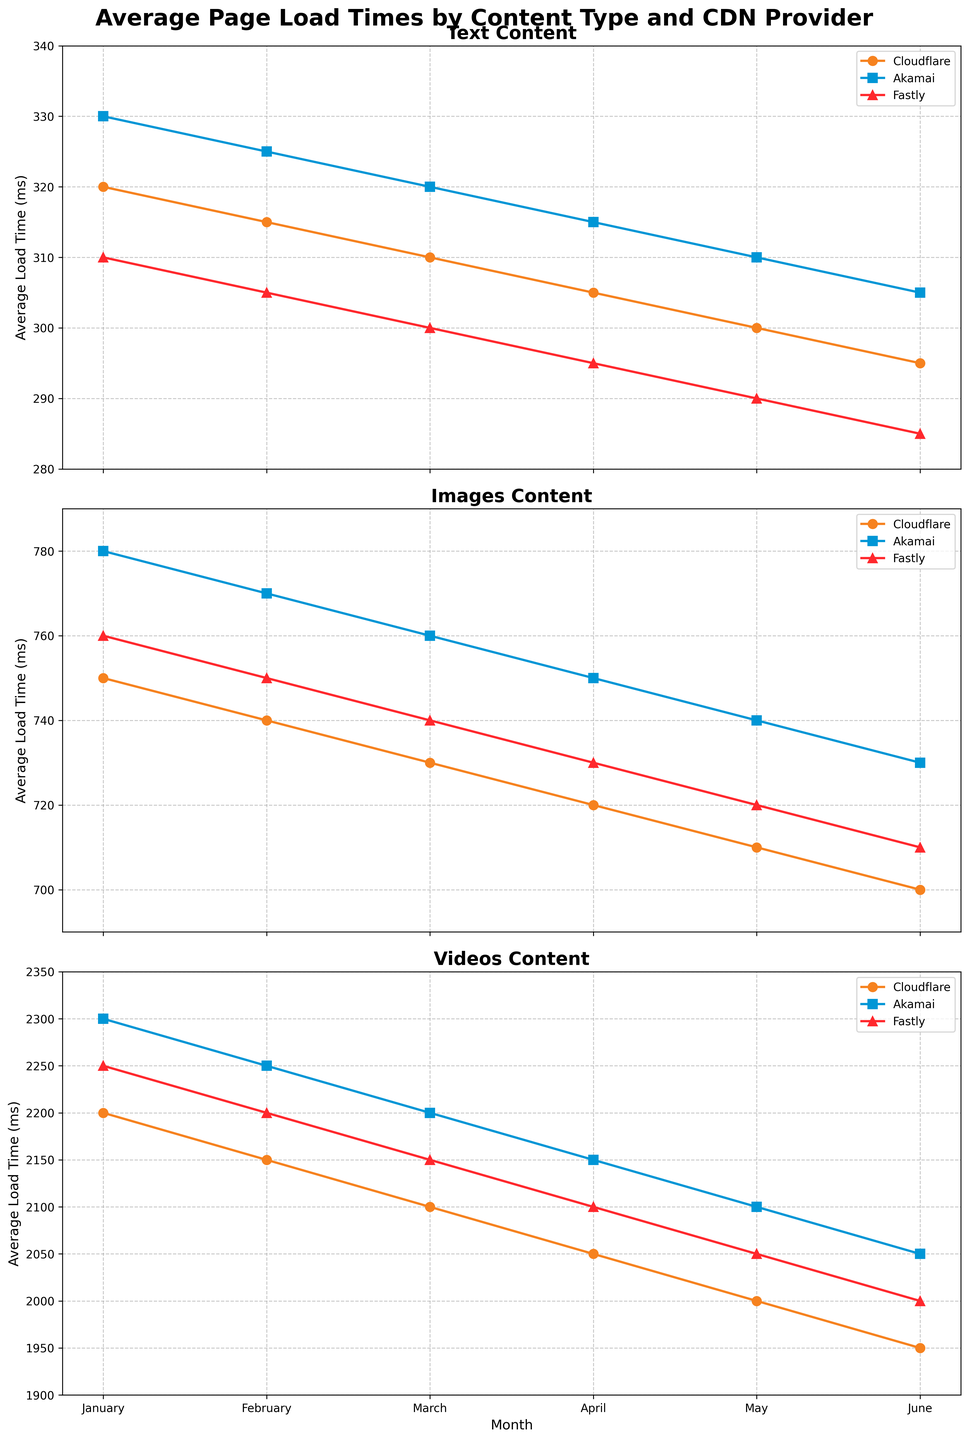Which CDN provider had the lowest average load time for text content in June? According to the figure, each CDN provider's performance for text content in June can be compared. Fastly shows the lowest average load time, with 285 ms.
Answer: Fastly By how much did the average load time for video content served by Cloudflare decrease from January to June? Cloudflare's video content load time in January was 2200 ms and decreased to 1950 ms in June. The difference is 2200 - 1950 = 250 ms.
Answer: 250 ms Compare the average load times for image content served by Akamai and Fastly in May. Which one was faster and by how much? In May, Akamai's average load time for image content was 740 ms, while Fastly's was 720 ms. Fastly was faster by 740 - 720 = 20 ms.
Answer: Fastly, by 20 ms What is the average load time for text content across all CDN providers in February? For February, the average load times for text content are: Cloudflare 315 ms, Akamai 325 ms, Fastly 305 ms. The overall average is (315 + 325 + 305) / 3 = 945 / 3 = 315 ms.
Answer: 315 ms Which content type had the highest average load time in January across all CDN providers? By examining the plots for each content type in January, video content shows the highest average load times. Cloudflare and Fastly are both around 2200 ms and Akamai is around 2300 ms.
Answer: Videos Which CDN provider consistently showed a monthly decrease in average load time for images? Observing the images section, Cloudflare shows a month-by-month decrease in load times, from 750 ms in January to 700 ms in June.
Answer: Cloudflare Between March and June, which CDN provider had the most significant reduction in load time for video content? For video content, Cloudflare's load times decreased from 2100 ms to 1950 ms, a reduction of 150 ms. Akamai shows a reduction of 150 ms (2200 ms to 2050 ms) and Fastly shows a reduction of 150 ms (also 2150 ms to 2000 ms). They all have the same significant reduction.
Answer: All had the same reduction What was the average load time in May for videos across all three CDN providers? The load times in May for videos are: Cloudflare 2000 ms, Akamai 2100 ms, Fastly 2050 ms. The average is (2000 + 2100 + 2050) / 3 = 6150 / 3 = 2050 ms.
Answer: 2050 ms Which month saw the lowest average load time for text content served by Akamai? For text content served by Akamai, June had the lowest average load time at 305 ms according to the plot.
Answer: June In the month of April, compare the load times for images between Cloudflare and Fastly. How much slower or faster was one compared to the other? In April, the average load time for images served by Cloudflare was 720 ms, while for Fastly it was 730 ms. Fastly was slower by 10 ms.
Answer: Fastly, by 10 ms 